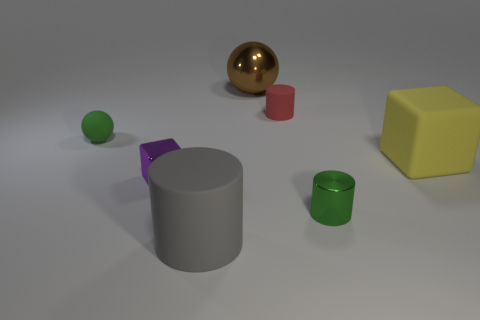Add 3 purple metallic things. How many objects exist? 10 Subtract all cylinders. How many objects are left? 4 Add 6 large gray matte cylinders. How many large gray matte cylinders are left? 7 Add 3 tiny green matte things. How many tiny green matte things exist? 4 Subtract 0 yellow cylinders. How many objects are left? 7 Subtract all matte spheres. Subtract all big red metal blocks. How many objects are left? 6 